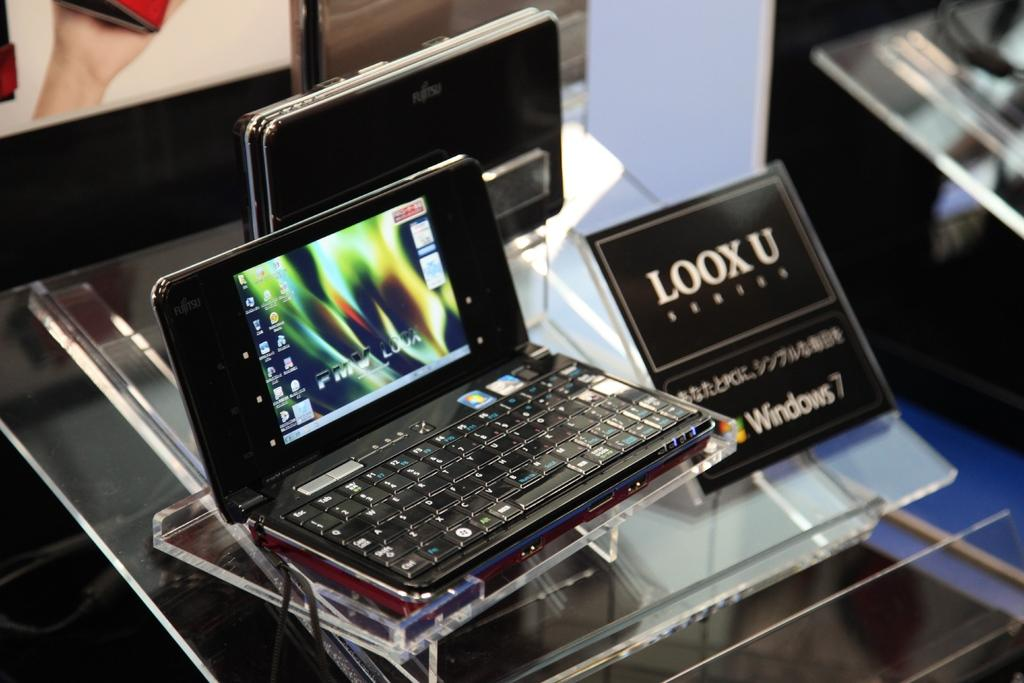Provide a one-sentence caption for the provided image. A very small lap top the size of a cell phone on display with a sign next to it that says Loox  U. 